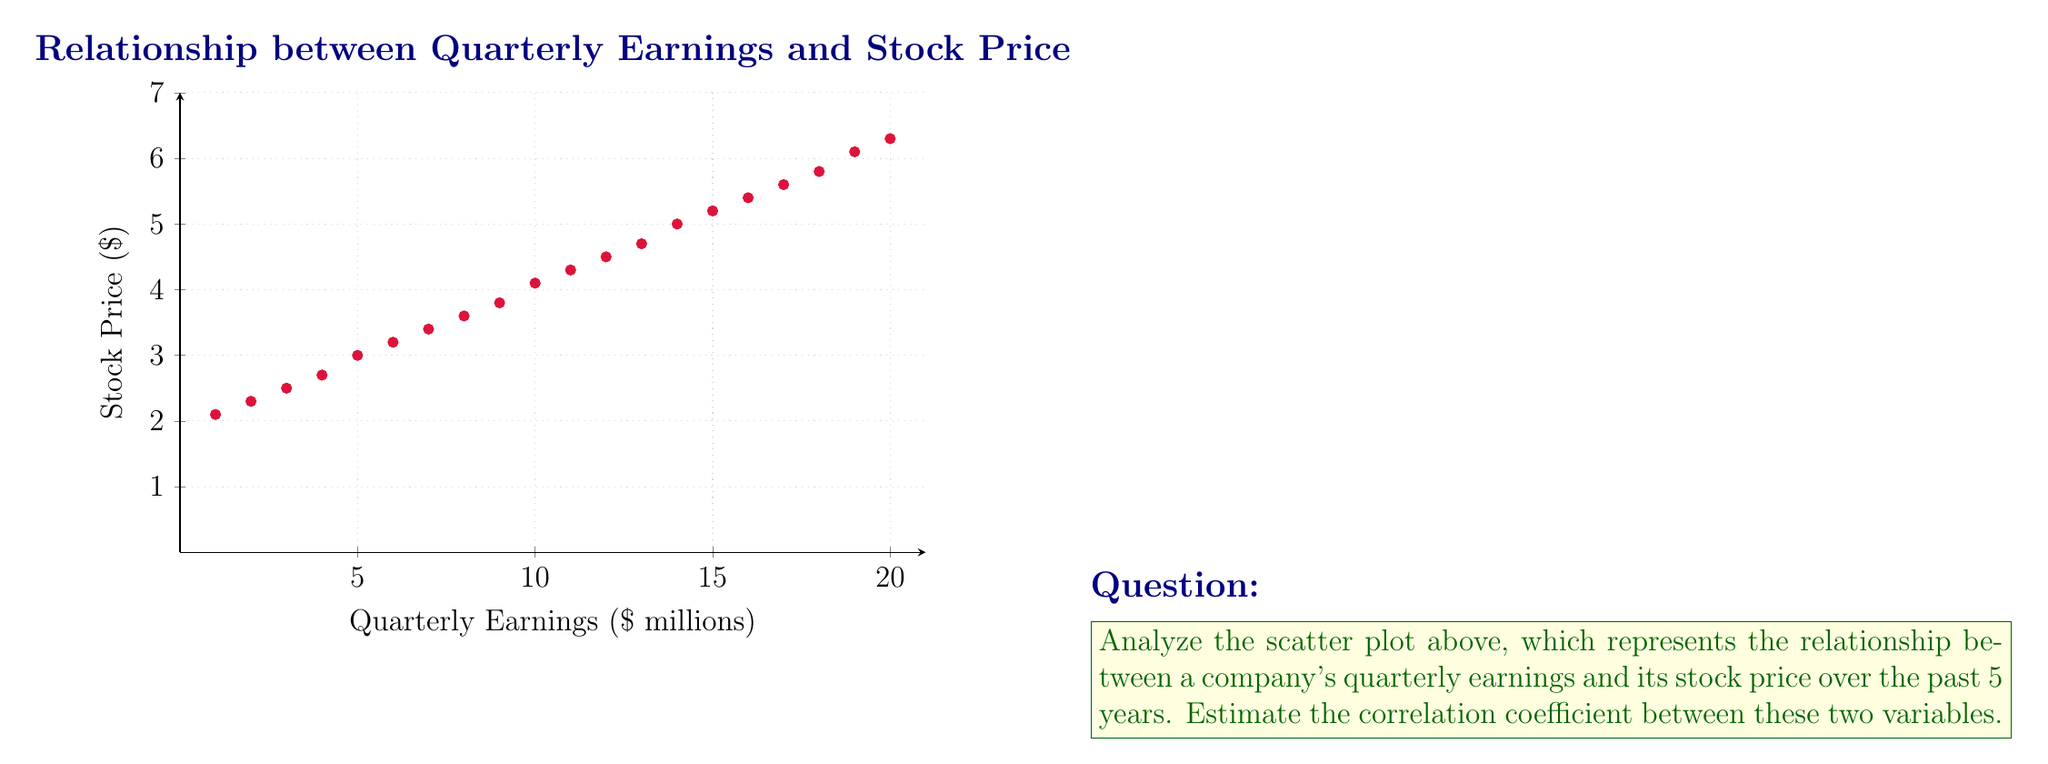Solve this math problem. To estimate the correlation coefficient from a scatter plot, we need to consider the following steps:

1. Direction: The points show a clear upward trend from left to right, indicating a positive correlation.

2. Linearity: The points roughly follow a straight line, suggesting a strong linear relationship.

3. Strength: The points are tightly clustered around an imaginary straight line, indicating a strong correlation.

4. Outliers: There are no apparent outliers that significantly deviate from the general trend.

Based on these observations, we can estimate the correlation coefficient using the following guidelines:

- Perfect positive correlation: $r = 1$
- Strong positive correlation: $0.7 < r < 1$
- Moderate positive correlation: $0.3 < r < 0.7$
- Weak positive correlation: $0 < r < 0.3$

Given the strong linear relationship, tight clustering, and absence of outliers, we can estimate that the correlation coefficient is likely to be between 0.9 and 1.

A reasonable estimate for this scatter plot would be $r \approx 0.95$.
Answer: $r \approx 0.95$ 